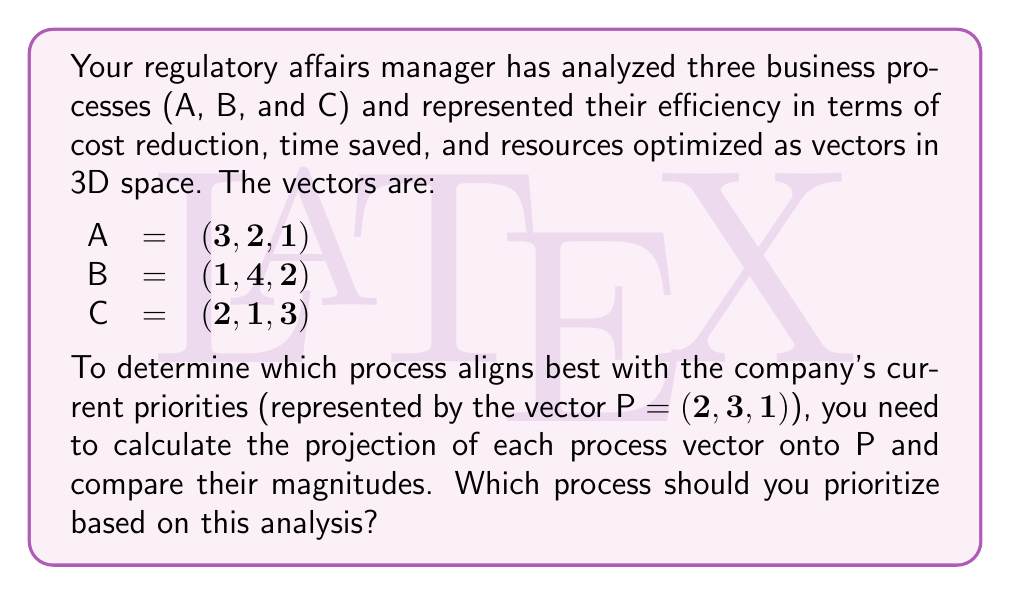Teach me how to tackle this problem. To solve this problem, we need to calculate the projection of each process vector (A, B, and C) onto the priority vector P and compare their magnitudes. The process with the largest projection magnitude will be the one that aligns best with the company's priorities.

The formula for vector projection of a onto b is:

$$\text{proj}_b a = \frac{a \cdot b}{||b||^2} b$$

Where $a \cdot b$ is the dot product and $||b||$ is the magnitude of vector b.

Step 1: Calculate $||P||^2$
$$||P||^2 = 2^2 + 3^2 + 1^2 = 4 + 9 + 1 = 14$$

Step 2: Calculate dot products
$$A \cdot P = 3(2) + 2(3) + 1(1) = 6 + 6 + 1 = 13$$
$$B \cdot P = 1(2) + 4(3) + 2(1) = 2 + 12 + 2 = 16$$
$$C \cdot P = 2(2) + 1(3) + 3(1) = 4 + 3 + 3 = 10$$

Step 3: Calculate projections
$$\text{proj}_P A = \frac{13}{14} P = \frac{13}{14}(2, 3, 1) = (\frac{13}{7}, \frac{39}{14}, \frac{13}{14})$$
$$\text{proj}_P B = \frac{16}{14} P = \frac{8}{7}(2, 3, 1) = (\frac{16}{7}, \frac{24}{7}, \frac{8}{7})$$
$$\text{proj}_P C = \frac{10}{14} P = \frac{5}{7}(2, 3, 1) = (\frac{10}{7}, \frac{15}{7}, \frac{5}{7})$$

Step 4: Calculate magnitudes of projections
$$||\text{proj}_P A|| = \sqrt{(\frac{13}{7})^2 + (\frac{39}{14})^2 + (\frac{13}{14})^2} \approx 3.4641$$
$$||\text{proj}_P B|| = \sqrt{(\frac{16}{7})^2 + (\frac{24}{7})^2 + (\frac{8}{7})^2} \approx 4.2426$$
$$||\text{proj}_P C|| = \sqrt{(\frac{10}{7})^2 + (\frac{15}{7})^2 + (\frac{5}{7})^2} \approx 2.6726$$

Step 5: Compare magnitudes
The largest projection magnitude is for process B (approximately 4.2426).
Answer: Based on the analysis, you should prioritize process B, as it has the largest projection magnitude onto the priority vector P, indicating the best alignment with the company's current priorities. 